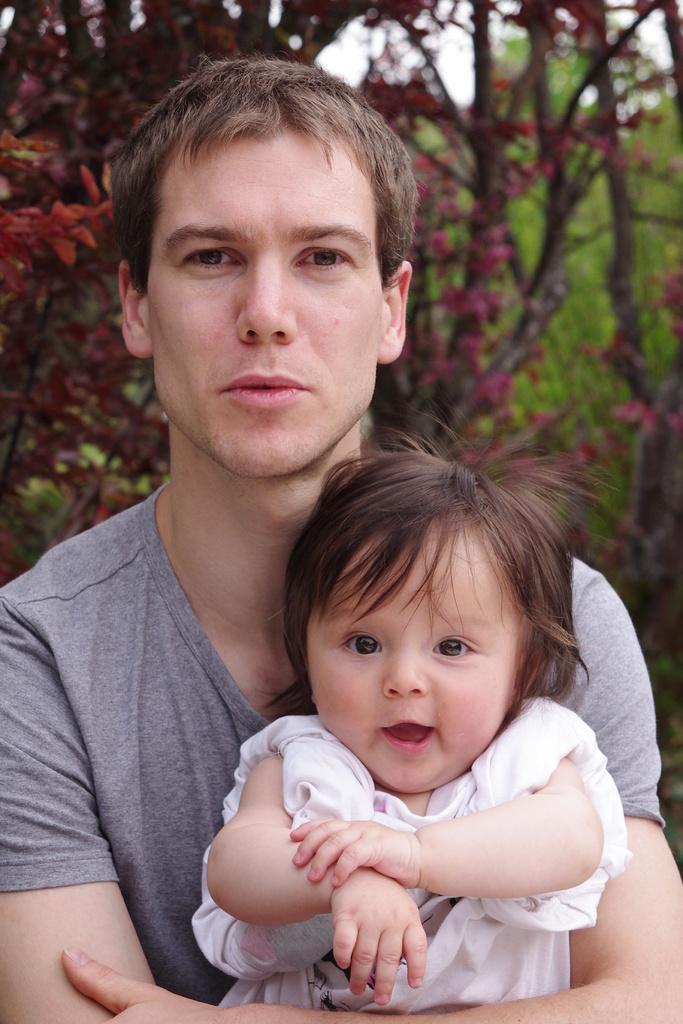How would you summarize this image in a sentence or two? In this image we can see two persons. Behind the persons we can see few trees. At the top we can see the sky. 